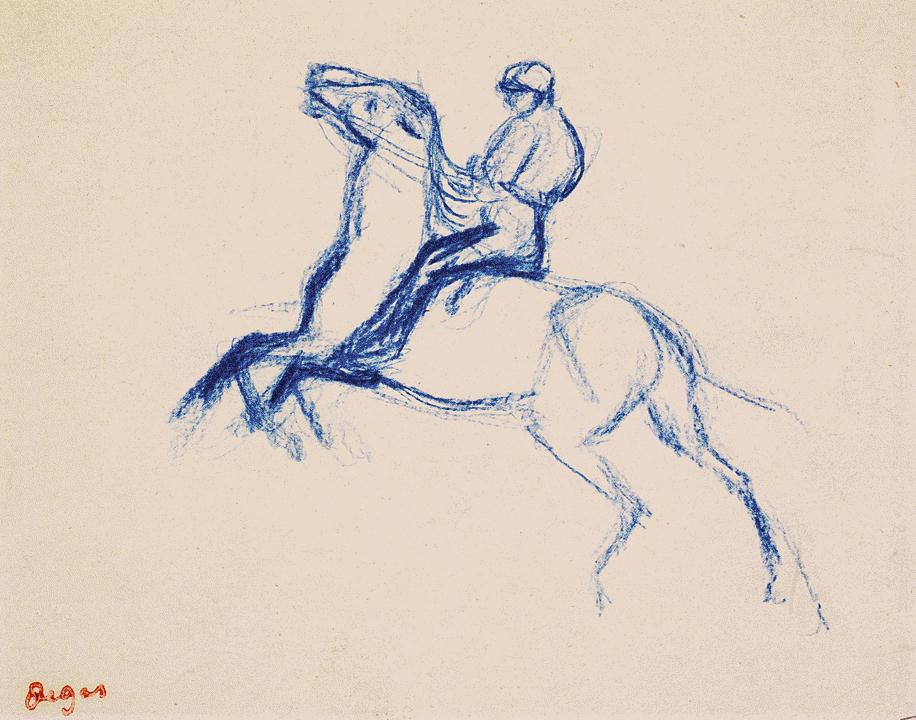What are the key elements in this picture? The image depicts an evocative impressionistic sketch of a person riding a horse. Rendered entirely in a dramatic blue hue against an unobtrusive white background, the image captures a strong sense of contrast and depth. The horse, drawn with a majestic and dynamic pose, is seen rearing up on its hind legs, suggesting a burst of energy or perhaps a sudden scare. The rider, clutching the reins tightly, appears synchronized with the horse’s vigorous movements, highlighting their deep rapport. This artwork fits within the equestrian genre, emphasizing the connection between horses and humans. The use of impressionism focuses on the overall scene impression rather than minute details, adding a sense of fluidity and vitality to the sketch. By choosing to use a single blue color, the artist accentuates the drama and emotional intensity of the scene, making the artwork compelling and visually engaging. 